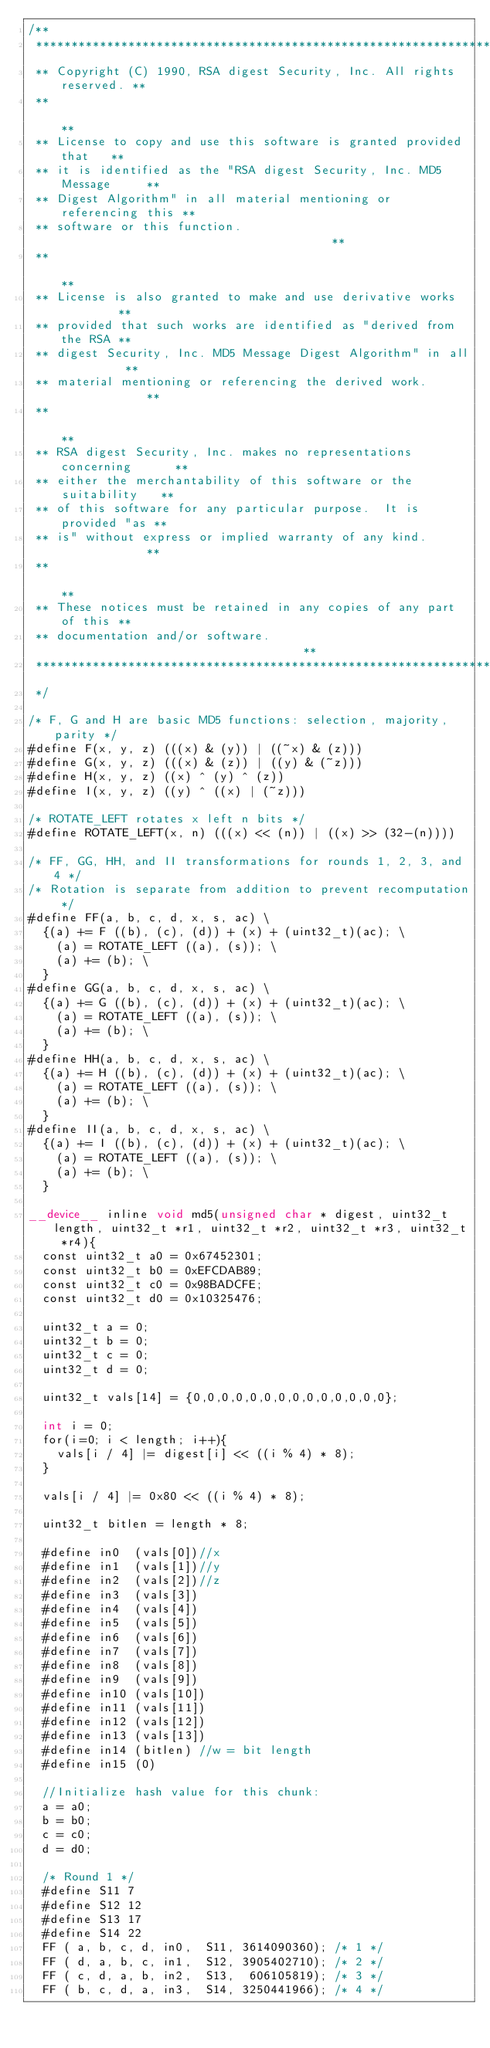Convert code to text. <code><loc_0><loc_0><loc_500><loc_500><_Cuda_>/**
 **********************************************************************
 ** Copyright (C) 1990, RSA digest Security, Inc. All rights reserved. **
 **                                                                  **
 ** License to copy and use this software is granted provided that   **
 ** it is identified as the "RSA digest Security, Inc. MD5 Message     **
 ** Digest Algorithm" in all material mentioning or referencing this **
 ** software or this function.                                       **
 **                                                                  **
 ** License is also granted to make and use derivative works         **
 ** provided that such works are identified as "derived from the RSA **
 ** digest Security, Inc. MD5 Message Digest Algorithm" in all         **
 ** material mentioning or referencing the derived work.             **
 **                                                                  **
 ** RSA digest Security, Inc. makes no representations concerning      **
 ** either the merchantability of this software or the suitability   **
 ** of this software for any particular purpose.  It is provided "as **
 ** is" without express or implied warranty of any kind.             **
 **                                                                  **
 ** These notices must be retained in any copies of any part of this **
 ** documentation and/or software.                                   **
 **********************************************************************
 */

/* F, G and H are basic MD5 functions: selection, majority, parity */
#define F(x, y, z) (((x) & (y)) | ((~x) & (z)))
#define G(x, y, z) (((x) & (z)) | ((y) & (~z)))
#define H(x, y, z) ((x) ^ (y) ^ (z))
#define I(x, y, z) ((y) ^ ((x) | (~z)))

/* ROTATE_LEFT rotates x left n bits */
#define ROTATE_LEFT(x, n) (((x) << (n)) | ((x) >> (32-(n))))

/* FF, GG, HH, and II transformations for rounds 1, 2, 3, and 4 */
/* Rotation is separate from addition to prevent recomputation */
#define FF(a, b, c, d, x, s, ac) \
  {(a) += F ((b), (c), (d)) + (x) + (uint32_t)(ac); \
    (a) = ROTATE_LEFT ((a), (s)); \
    (a) += (b); \
  }
#define GG(a, b, c, d, x, s, ac) \
  {(a) += G ((b), (c), (d)) + (x) + (uint32_t)(ac); \
    (a) = ROTATE_LEFT ((a), (s)); \
    (a) += (b); \
  }
#define HH(a, b, c, d, x, s, ac) \
  {(a) += H ((b), (c), (d)) + (x) + (uint32_t)(ac); \
    (a) = ROTATE_LEFT ((a), (s)); \
    (a) += (b); \
  }
#define II(a, b, c, d, x, s, ac) \
  {(a) += I ((b), (c), (d)) + (x) + (uint32_t)(ac); \
    (a) = ROTATE_LEFT ((a), (s)); \
    (a) += (b); \
  }

__device__ inline void md5(unsigned char * digest, uint32_t length, uint32_t *r1, uint32_t *r2, uint32_t *r3, uint32_t *r4){
  const uint32_t a0 = 0x67452301;
  const uint32_t b0 = 0xEFCDAB89;
  const uint32_t c0 = 0x98BADCFE;
  const uint32_t d0 = 0x10325476;

  uint32_t a = 0;
  uint32_t b = 0;
  uint32_t c = 0;
  uint32_t d = 0;

  uint32_t vals[14] = {0,0,0,0,0,0,0,0,0,0,0,0,0,0};

  int i = 0;
  for(i=0; i < length; i++){
    vals[i / 4] |= digest[i] << ((i % 4) * 8);
  }
  
  vals[i / 4] |= 0x80 << ((i % 4) * 8);

  uint32_t bitlen = length * 8;

  #define in0  (vals[0])//x
  #define in1  (vals[1])//y
  #define in2  (vals[2])//z
  #define in3  (vals[3])
  #define in4  (vals[4])
  #define in5  (vals[5])
  #define in6  (vals[6])
  #define in7  (vals[7])
  #define in8  (vals[8])
  #define in9  (vals[9])
  #define in10 (vals[10])
  #define in11 (vals[11])
  #define in12 (vals[12])
  #define in13 (vals[13])
  #define in14 (bitlen) //w = bit length
  #define in15 (0)

  //Initialize hash value for this chunk:
  a = a0;
  b = b0;
  c = c0;
  d = d0;

  /* Round 1 */
  #define S11 7
  #define S12 12
  #define S13 17
  #define S14 22
  FF ( a, b, c, d, in0,  S11, 3614090360); /* 1 */
  FF ( d, a, b, c, in1,  S12, 3905402710); /* 2 */
  FF ( c, d, a, b, in2,  S13,  606105819); /* 3 */
  FF ( b, c, d, a, in3,  S14, 3250441966); /* 4 */</code> 